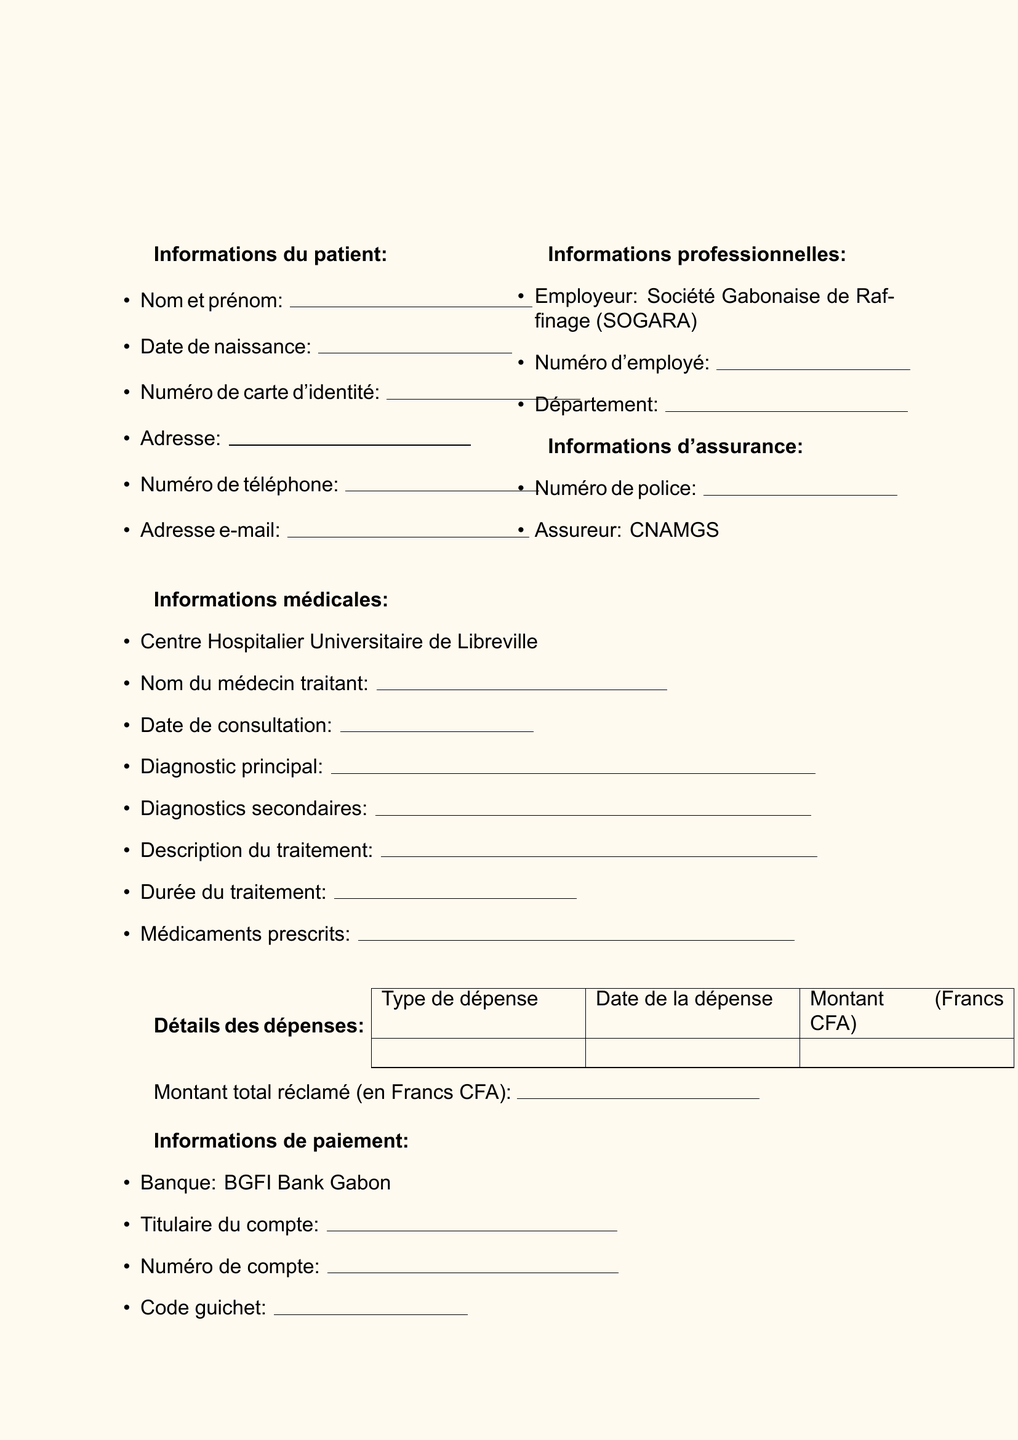what is the patient's full name? The patient's full name field requires the complete name of the person submitting the claim.
Answer: Nom et prénom what is the date of consultation? The date of consultation is a required field indicating when the medical consultation took place.
Answer: Date de consultation what is the employer's name? The employer's name is specified in the employment information section of the form.
Answer: Société Gabonaise de Raffinage (SOGARA) what is the total claim amount? The total claim amount represents the sum of all medical expenses being claimed on the form.
Answer: Montant total réclamé (en Francs CFA) what documents are required to be attached? The form lists several documents that must be submitted alongside the claim for verification.
Answer: Factures originales, Ordonnances médicales, Rapports médicaux, Résultats d'examens what is the purpose of the declarations? The declarations section is meant for the patient to affirm the accuracy of the information provided and authorize information sharing.
Answer: To confirm accuracy and authorize information sharing which bank is used for payment information? The bank name field indicates where the payment for the claim will be processed.
Answer: BGFI Bank Gabon how many types of diagnoses are mentioned? The medical information section includes a primary diagnosis and possible secondary diagnoses, indicating the types of diagnoses mentioned.
Answer: Two 